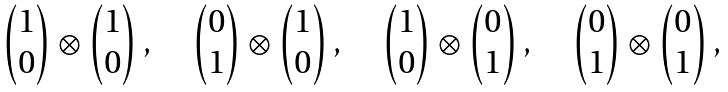Convert formula to latex. <formula><loc_0><loc_0><loc_500><loc_500>\begin{array} { r c l } \begin{pmatrix} 1 \\ 0 \end{pmatrix} \otimes \begin{pmatrix} 1 \\ 0 \end{pmatrix} , \quad \begin{pmatrix} 0 \\ 1 \end{pmatrix} \otimes \begin{pmatrix} 1 \\ 0 \end{pmatrix} , \quad \begin{pmatrix} 1 \\ 0 \end{pmatrix} \otimes \begin{pmatrix} 0 \\ 1 \end{pmatrix} , \quad \begin{pmatrix} 0 \\ 1 \end{pmatrix} \otimes \begin{pmatrix} 0 \\ 1 \end{pmatrix} , \end{array}</formula> 